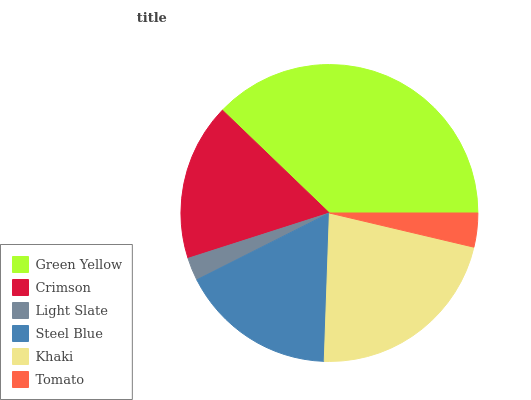Is Light Slate the minimum?
Answer yes or no. Yes. Is Green Yellow the maximum?
Answer yes or no. Yes. Is Crimson the minimum?
Answer yes or no. No. Is Crimson the maximum?
Answer yes or no. No. Is Green Yellow greater than Crimson?
Answer yes or no. Yes. Is Crimson less than Green Yellow?
Answer yes or no. Yes. Is Crimson greater than Green Yellow?
Answer yes or no. No. Is Green Yellow less than Crimson?
Answer yes or no. No. Is Crimson the high median?
Answer yes or no. Yes. Is Steel Blue the low median?
Answer yes or no. Yes. Is Steel Blue the high median?
Answer yes or no. No. Is Crimson the low median?
Answer yes or no. No. 